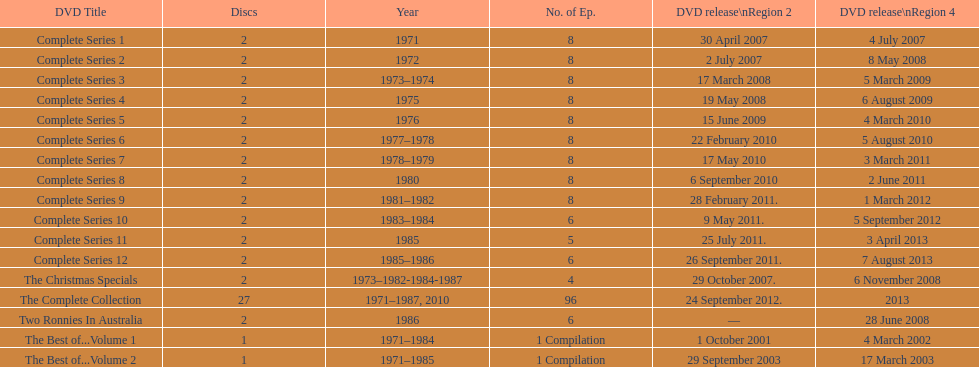How many "best of" volumes bring together the finest episodes of the tv program "the two ronnies"? 2. 